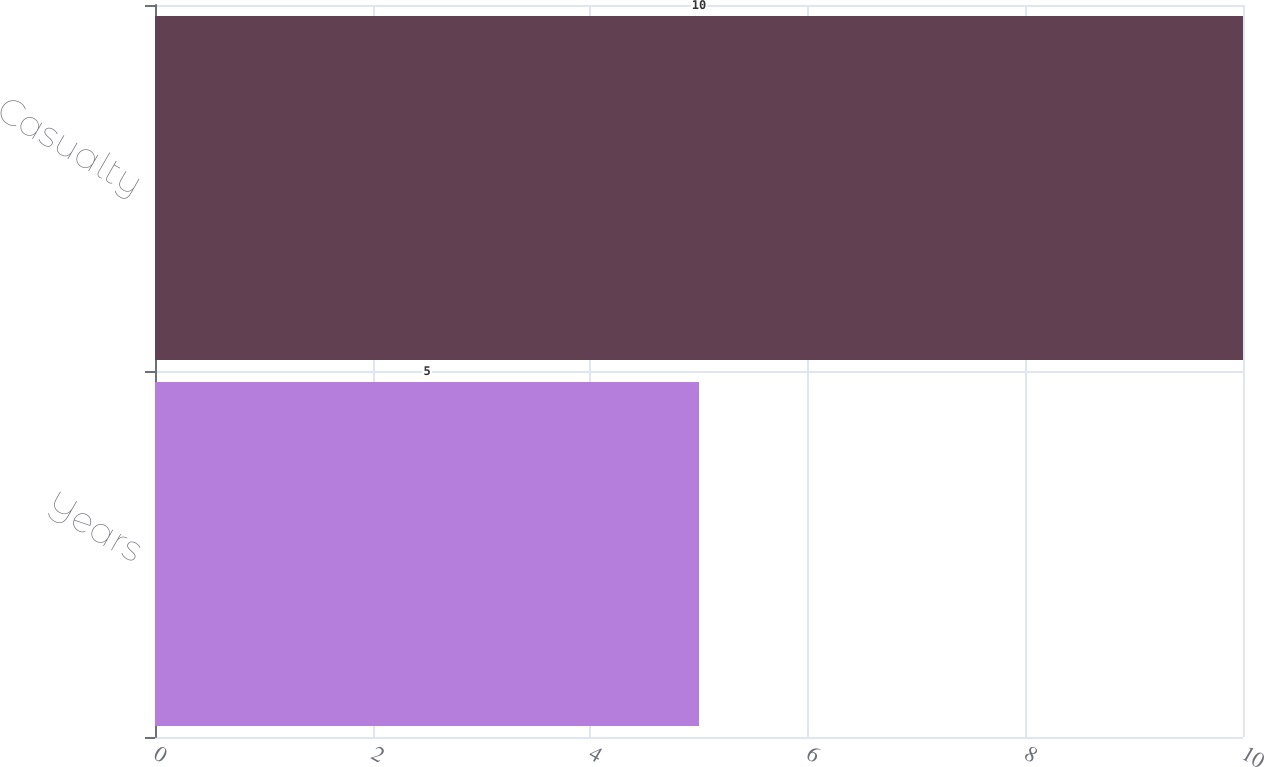<chart> <loc_0><loc_0><loc_500><loc_500><bar_chart><fcel>Years<fcel>Casualty<nl><fcel>5<fcel>10<nl></chart> 